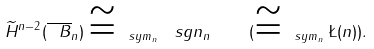<formula> <loc_0><loc_0><loc_500><loc_500>\widetilde { H } ^ { n - 2 } ( \overline { \ B } _ { n } ) \cong _ { \ s y m _ { n } } \ s g n _ { n } \quad ( \cong _ { \ s y m _ { n } } \L ( n ) ) .</formula> 